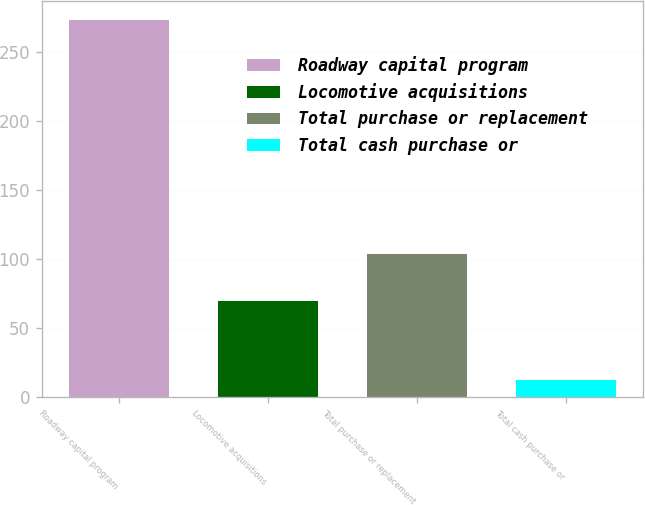Convert chart to OTSL. <chart><loc_0><loc_0><loc_500><loc_500><bar_chart><fcel>Roadway capital program<fcel>Locomotive acquisitions<fcel>Total purchase or replacement<fcel>Total cash purchase or<nl><fcel>273.8<fcel>69.8<fcel>103.9<fcel>12.8<nl></chart> 